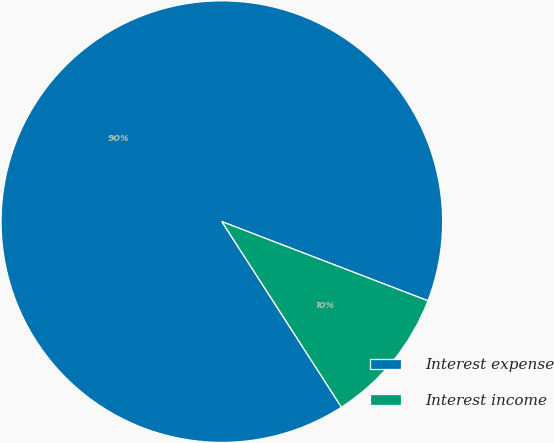Convert chart. <chart><loc_0><loc_0><loc_500><loc_500><pie_chart><fcel>Interest expense<fcel>Interest income<nl><fcel>89.95%<fcel>10.05%<nl></chart> 